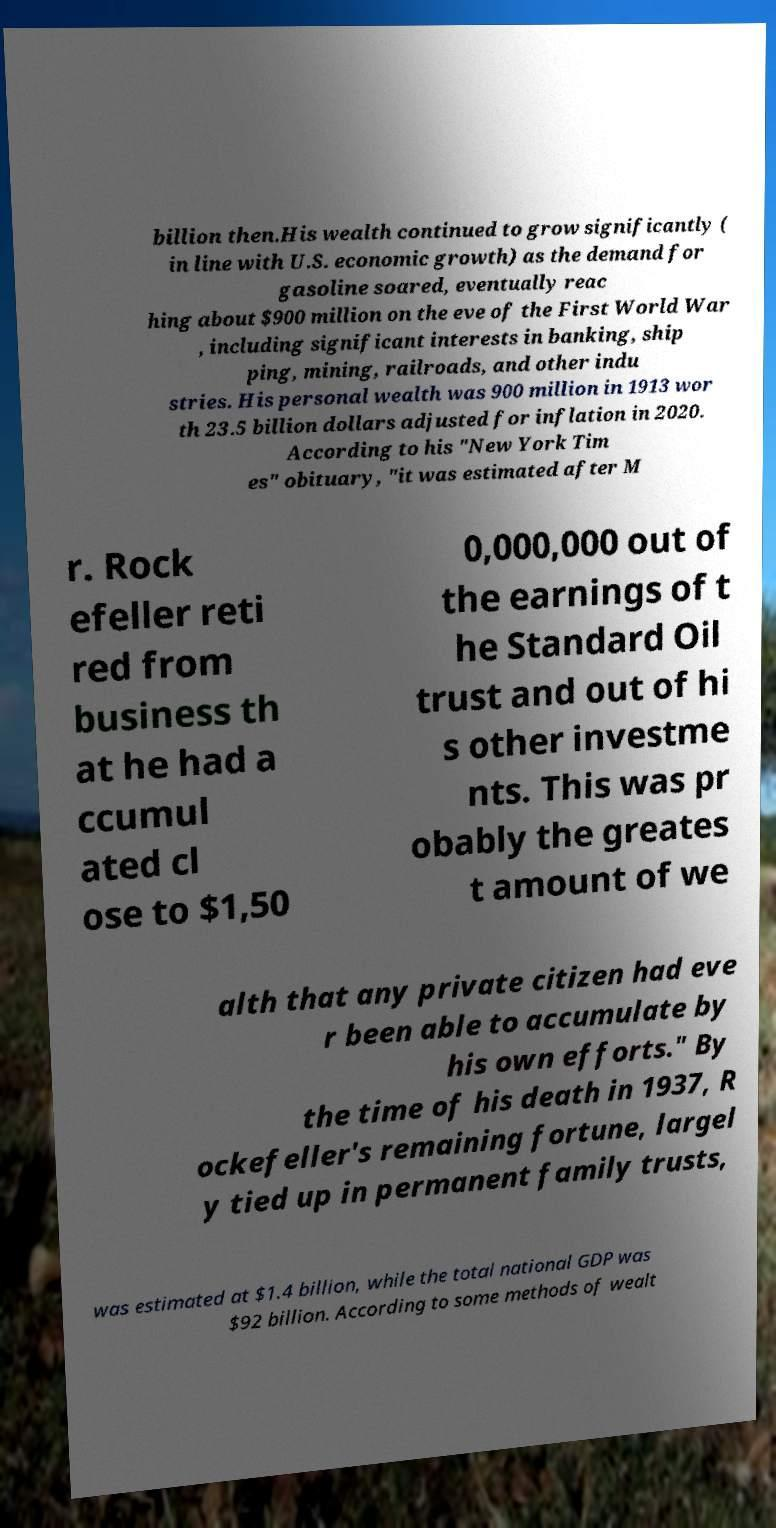Please identify and transcribe the text found in this image. billion then.His wealth continued to grow significantly ( in line with U.S. economic growth) as the demand for gasoline soared, eventually reac hing about $900 million on the eve of the First World War , including significant interests in banking, ship ping, mining, railroads, and other indu stries. His personal wealth was 900 million in 1913 wor th 23.5 billion dollars adjusted for inflation in 2020. According to his "New York Tim es" obituary, "it was estimated after M r. Rock efeller reti red from business th at he had a ccumul ated cl ose to $1,50 0,000,000 out of the earnings of t he Standard Oil trust and out of hi s other investme nts. This was pr obably the greates t amount of we alth that any private citizen had eve r been able to accumulate by his own efforts." By the time of his death in 1937, R ockefeller's remaining fortune, largel y tied up in permanent family trusts, was estimated at $1.4 billion, while the total national GDP was $92 billion. According to some methods of wealt 